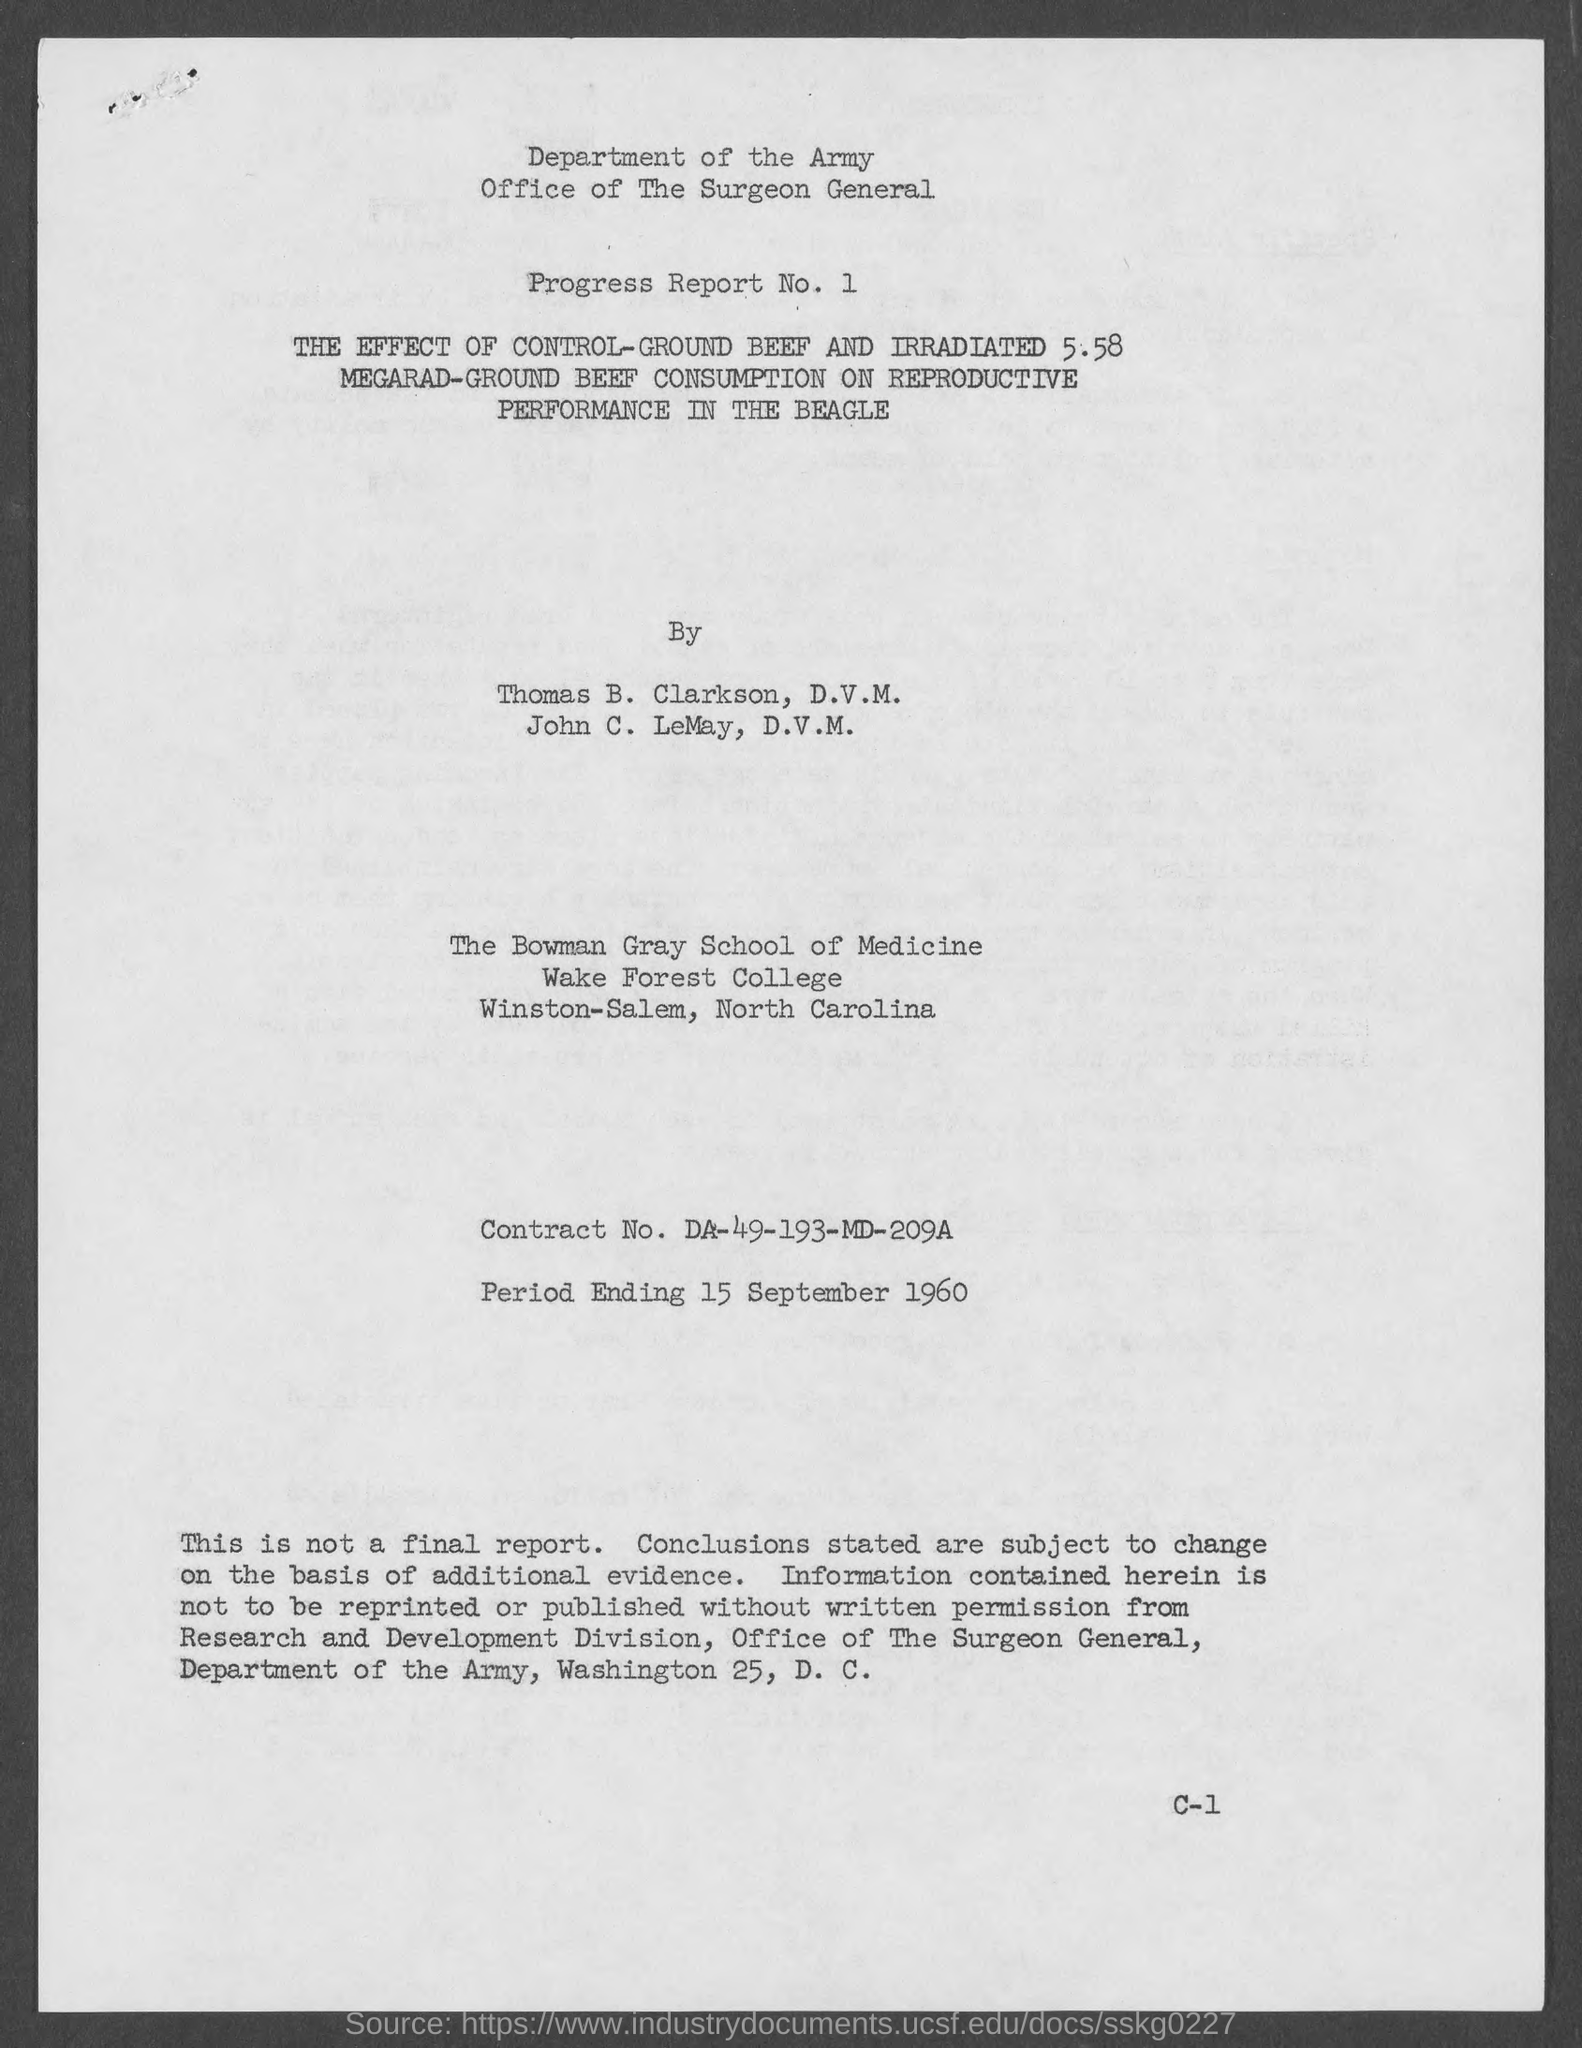Point out several critical features in this image. The Contract Number is da-49-193-md-209a.. The Bowman Gray School of Medicine is situated in Winston-Salem, North Carolina. 